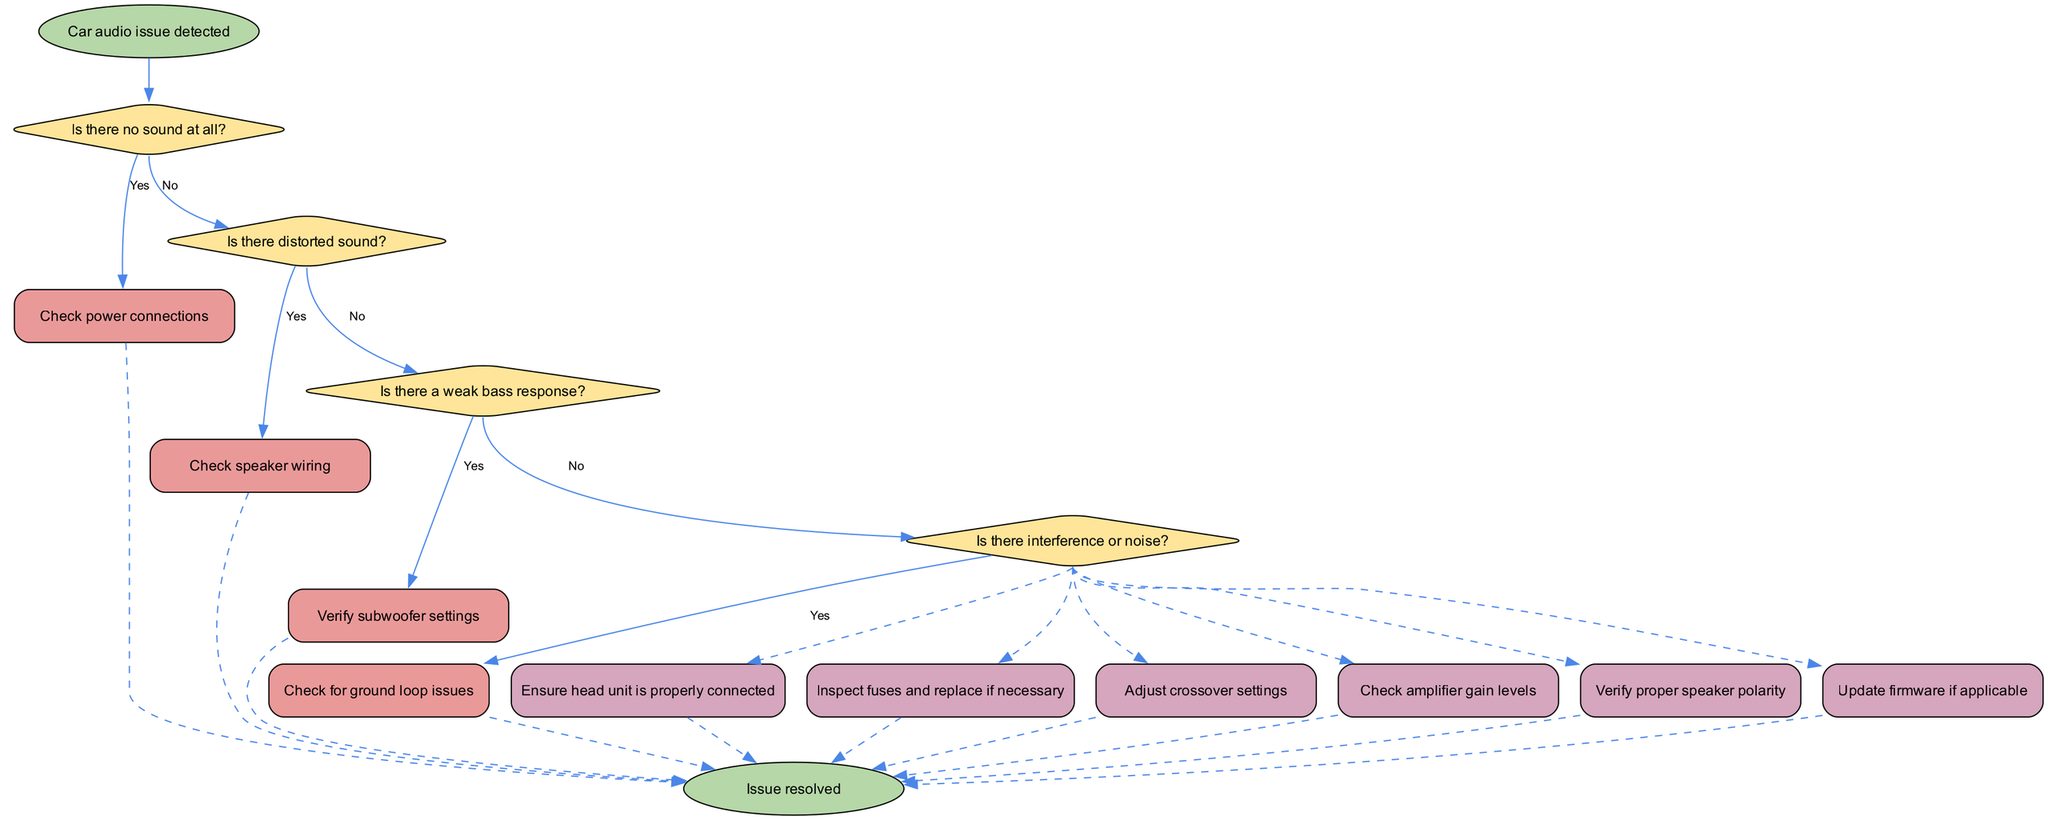What is the first question in the diagram? The first question is found at the top decision node, which addresses the scenario of having no sound at all.
Answer: Is there no sound at all? How many decisions are there in the flowchart? The flowchart contains a total of four decision nodes that collectively address different audio issues.
Answer: Four What action is suggested after checking for distorted sound? After confirming that there is distorted sound, the solution is to check the speaker wiring before proceeding further.
Answer: Check speaker wiring Which condition leads to the action of verifying subwoofer settings? The condition that leads to verifying subwoofer settings is when there is a weak bass response identified in the audio output.
Answer: Weak bass response What happens if there is interference or noise? If interference or noise is detected, the recommended action is to check for ground loop issues, which leads towards resolving the issue.
Answer: Check for ground loop issues What action should be taken if the issue persists after the last decision? If the issue persists after addressing all prior decisions, the next step is to consult a car audio specialist.
Answer: Consult car audio specialist How does the flowchart conclude? The flowchart concludes successfully at the end node labeled "Issue resolved," indicating that the troubleshooting process has been completed.
Answer: Issue resolved Which action follows the check for power connections if there is no sound at all? Following the check for power connections, the next step is to inspect fuses and replace them if necessary, as part of troubleshooting the issue.
Answer: Inspect fuses and replace if necessary 